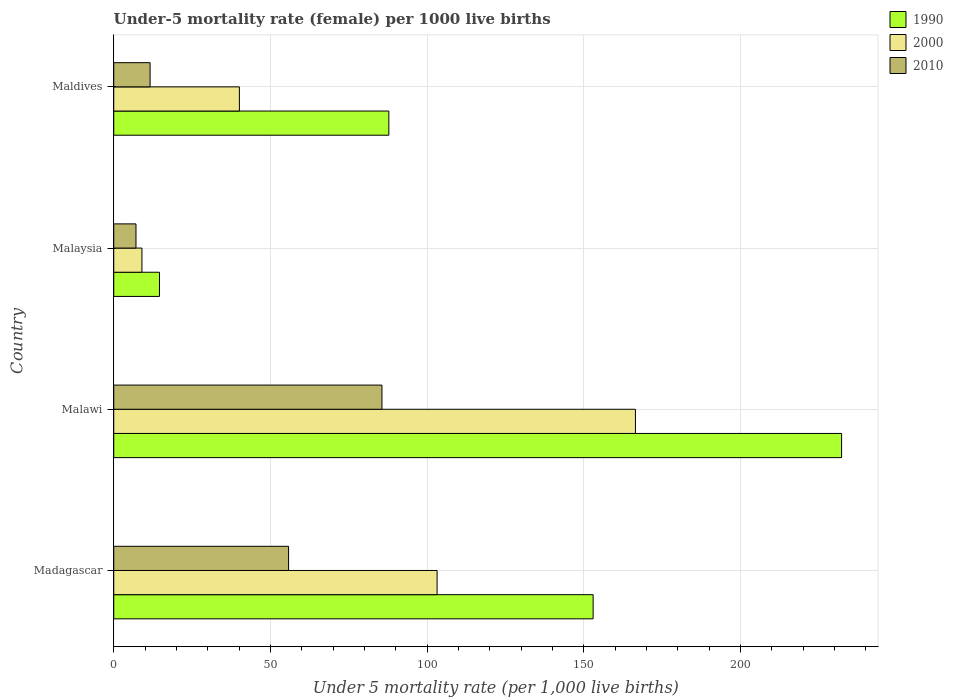What is the label of the 1st group of bars from the top?
Provide a short and direct response. Maldives. What is the under-five mortality rate in 2010 in Maldives?
Your response must be concise. 11.6. Across all countries, what is the maximum under-five mortality rate in 2000?
Give a very brief answer. 166.5. In which country was the under-five mortality rate in 2000 maximum?
Ensure brevity in your answer.  Malawi. In which country was the under-five mortality rate in 2010 minimum?
Provide a short and direct response. Malaysia. What is the total under-five mortality rate in 2000 in the graph?
Offer a very short reply. 318.8. What is the difference between the under-five mortality rate in 2000 in Malawi and that in Maldives?
Give a very brief answer. 126.4. What is the difference between the under-five mortality rate in 1990 in Malaysia and the under-five mortality rate in 2000 in Maldives?
Give a very brief answer. -25.5. What is the average under-five mortality rate in 2000 per country?
Make the answer very short. 79.7. What is the difference between the under-five mortality rate in 2010 and under-five mortality rate in 2000 in Madagascar?
Keep it short and to the point. -47.4. In how many countries, is the under-five mortality rate in 2010 greater than 140 ?
Ensure brevity in your answer.  0. Is the under-five mortality rate in 2000 in Malaysia less than that in Maldives?
Make the answer very short. Yes. What is the difference between the highest and the second highest under-five mortality rate in 2010?
Your answer should be very brief. 29.8. What is the difference between the highest and the lowest under-five mortality rate in 1990?
Offer a very short reply. 217.7. In how many countries, is the under-five mortality rate in 2010 greater than the average under-five mortality rate in 2010 taken over all countries?
Make the answer very short. 2. What does the 2nd bar from the top in Malawi represents?
Offer a very short reply. 2000. Are all the bars in the graph horizontal?
Offer a terse response. Yes. Does the graph contain any zero values?
Provide a succinct answer. No. Does the graph contain grids?
Provide a succinct answer. Yes. What is the title of the graph?
Make the answer very short. Under-5 mortality rate (female) per 1000 live births. What is the label or title of the X-axis?
Keep it short and to the point. Under 5 mortality rate (per 1,0 live births). What is the label or title of the Y-axis?
Provide a succinct answer. Country. What is the Under 5 mortality rate (per 1,000 live births) in 1990 in Madagascar?
Offer a very short reply. 153. What is the Under 5 mortality rate (per 1,000 live births) in 2000 in Madagascar?
Your answer should be very brief. 103.2. What is the Under 5 mortality rate (per 1,000 live births) in 2010 in Madagascar?
Provide a succinct answer. 55.8. What is the Under 5 mortality rate (per 1,000 live births) in 1990 in Malawi?
Your response must be concise. 232.3. What is the Under 5 mortality rate (per 1,000 live births) of 2000 in Malawi?
Offer a terse response. 166.5. What is the Under 5 mortality rate (per 1,000 live births) in 2010 in Malawi?
Keep it short and to the point. 85.6. What is the Under 5 mortality rate (per 1,000 live births) in 2000 in Malaysia?
Provide a succinct answer. 9. What is the Under 5 mortality rate (per 1,000 live births) in 1990 in Maldives?
Your answer should be compact. 87.8. What is the Under 5 mortality rate (per 1,000 live births) of 2000 in Maldives?
Make the answer very short. 40.1. What is the Under 5 mortality rate (per 1,000 live births) in 2010 in Maldives?
Your response must be concise. 11.6. Across all countries, what is the maximum Under 5 mortality rate (per 1,000 live births) in 1990?
Make the answer very short. 232.3. Across all countries, what is the maximum Under 5 mortality rate (per 1,000 live births) of 2000?
Your answer should be very brief. 166.5. Across all countries, what is the maximum Under 5 mortality rate (per 1,000 live births) of 2010?
Offer a very short reply. 85.6. Across all countries, what is the minimum Under 5 mortality rate (per 1,000 live births) of 2000?
Offer a terse response. 9. Across all countries, what is the minimum Under 5 mortality rate (per 1,000 live births) of 2010?
Make the answer very short. 7.1. What is the total Under 5 mortality rate (per 1,000 live births) in 1990 in the graph?
Your answer should be compact. 487.7. What is the total Under 5 mortality rate (per 1,000 live births) of 2000 in the graph?
Your answer should be very brief. 318.8. What is the total Under 5 mortality rate (per 1,000 live births) of 2010 in the graph?
Provide a succinct answer. 160.1. What is the difference between the Under 5 mortality rate (per 1,000 live births) in 1990 in Madagascar and that in Malawi?
Give a very brief answer. -79.3. What is the difference between the Under 5 mortality rate (per 1,000 live births) of 2000 in Madagascar and that in Malawi?
Provide a succinct answer. -63.3. What is the difference between the Under 5 mortality rate (per 1,000 live births) of 2010 in Madagascar and that in Malawi?
Ensure brevity in your answer.  -29.8. What is the difference between the Under 5 mortality rate (per 1,000 live births) of 1990 in Madagascar and that in Malaysia?
Ensure brevity in your answer.  138.4. What is the difference between the Under 5 mortality rate (per 1,000 live births) of 2000 in Madagascar and that in Malaysia?
Your response must be concise. 94.2. What is the difference between the Under 5 mortality rate (per 1,000 live births) of 2010 in Madagascar and that in Malaysia?
Provide a short and direct response. 48.7. What is the difference between the Under 5 mortality rate (per 1,000 live births) of 1990 in Madagascar and that in Maldives?
Offer a very short reply. 65.2. What is the difference between the Under 5 mortality rate (per 1,000 live births) of 2000 in Madagascar and that in Maldives?
Your answer should be compact. 63.1. What is the difference between the Under 5 mortality rate (per 1,000 live births) of 2010 in Madagascar and that in Maldives?
Ensure brevity in your answer.  44.2. What is the difference between the Under 5 mortality rate (per 1,000 live births) of 1990 in Malawi and that in Malaysia?
Your response must be concise. 217.7. What is the difference between the Under 5 mortality rate (per 1,000 live births) of 2000 in Malawi and that in Malaysia?
Offer a terse response. 157.5. What is the difference between the Under 5 mortality rate (per 1,000 live births) of 2010 in Malawi and that in Malaysia?
Provide a short and direct response. 78.5. What is the difference between the Under 5 mortality rate (per 1,000 live births) in 1990 in Malawi and that in Maldives?
Provide a short and direct response. 144.5. What is the difference between the Under 5 mortality rate (per 1,000 live births) in 2000 in Malawi and that in Maldives?
Your answer should be compact. 126.4. What is the difference between the Under 5 mortality rate (per 1,000 live births) in 1990 in Malaysia and that in Maldives?
Your response must be concise. -73.2. What is the difference between the Under 5 mortality rate (per 1,000 live births) of 2000 in Malaysia and that in Maldives?
Ensure brevity in your answer.  -31.1. What is the difference between the Under 5 mortality rate (per 1,000 live births) in 1990 in Madagascar and the Under 5 mortality rate (per 1,000 live births) in 2010 in Malawi?
Provide a succinct answer. 67.4. What is the difference between the Under 5 mortality rate (per 1,000 live births) of 2000 in Madagascar and the Under 5 mortality rate (per 1,000 live births) of 2010 in Malawi?
Provide a succinct answer. 17.6. What is the difference between the Under 5 mortality rate (per 1,000 live births) in 1990 in Madagascar and the Under 5 mortality rate (per 1,000 live births) in 2000 in Malaysia?
Your response must be concise. 144. What is the difference between the Under 5 mortality rate (per 1,000 live births) of 1990 in Madagascar and the Under 5 mortality rate (per 1,000 live births) of 2010 in Malaysia?
Make the answer very short. 145.9. What is the difference between the Under 5 mortality rate (per 1,000 live births) of 2000 in Madagascar and the Under 5 mortality rate (per 1,000 live births) of 2010 in Malaysia?
Your response must be concise. 96.1. What is the difference between the Under 5 mortality rate (per 1,000 live births) of 1990 in Madagascar and the Under 5 mortality rate (per 1,000 live births) of 2000 in Maldives?
Provide a short and direct response. 112.9. What is the difference between the Under 5 mortality rate (per 1,000 live births) of 1990 in Madagascar and the Under 5 mortality rate (per 1,000 live births) of 2010 in Maldives?
Provide a succinct answer. 141.4. What is the difference between the Under 5 mortality rate (per 1,000 live births) of 2000 in Madagascar and the Under 5 mortality rate (per 1,000 live births) of 2010 in Maldives?
Keep it short and to the point. 91.6. What is the difference between the Under 5 mortality rate (per 1,000 live births) of 1990 in Malawi and the Under 5 mortality rate (per 1,000 live births) of 2000 in Malaysia?
Your answer should be compact. 223.3. What is the difference between the Under 5 mortality rate (per 1,000 live births) in 1990 in Malawi and the Under 5 mortality rate (per 1,000 live births) in 2010 in Malaysia?
Give a very brief answer. 225.2. What is the difference between the Under 5 mortality rate (per 1,000 live births) of 2000 in Malawi and the Under 5 mortality rate (per 1,000 live births) of 2010 in Malaysia?
Your answer should be compact. 159.4. What is the difference between the Under 5 mortality rate (per 1,000 live births) in 1990 in Malawi and the Under 5 mortality rate (per 1,000 live births) in 2000 in Maldives?
Make the answer very short. 192.2. What is the difference between the Under 5 mortality rate (per 1,000 live births) in 1990 in Malawi and the Under 5 mortality rate (per 1,000 live births) in 2010 in Maldives?
Your response must be concise. 220.7. What is the difference between the Under 5 mortality rate (per 1,000 live births) in 2000 in Malawi and the Under 5 mortality rate (per 1,000 live births) in 2010 in Maldives?
Your answer should be compact. 154.9. What is the difference between the Under 5 mortality rate (per 1,000 live births) in 1990 in Malaysia and the Under 5 mortality rate (per 1,000 live births) in 2000 in Maldives?
Ensure brevity in your answer.  -25.5. What is the difference between the Under 5 mortality rate (per 1,000 live births) in 2000 in Malaysia and the Under 5 mortality rate (per 1,000 live births) in 2010 in Maldives?
Keep it short and to the point. -2.6. What is the average Under 5 mortality rate (per 1,000 live births) of 1990 per country?
Your response must be concise. 121.92. What is the average Under 5 mortality rate (per 1,000 live births) in 2000 per country?
Provide a succinct answer. 79.7. What is the average Under 5 mortality rate (per 1,000 live births) of 2010 per country?
Provide a short and direct response. 40.02. What is the difference between the Under 5 mortality rate (per 1,000 live births) in 1990 and Under 5 mortality rate (per 1,000 live births) in 2000 in Madagascar?
Ensure brevity in your answer.  49.8. What is the difference between the Under 5 mortality rate (per 1,000 live births) in 1990 and Under 5 mortality rate (per 1,000 live births) in 2010 in Madagascar?
Make the answer very short. 97.2. What is the difference between the Under 5 mortality rate (per 1,000 live births) of 2000 and Under 5 mortality rate (per 1,000 live births) of 2010 in Madagascar?
Provide a succinct answer. 47.4. What is the difference between the Under 5 mortality rate (per 1,000 live births) of 1990 and Under 5 mortality rate (per 1,000 live births) of 2000 in Malawi?
Make the answer very short. 65.8. What is the difference between the Under 5 mortality rate (per 1,000 live births) of 1990 and Under 5 mortality rate (per 1,000 live births) of 2010 in Malawi?
Provide a succinct answer. 146.7. What is the difference between the Under 5 mortality rate (per 1,000 live births) in 2000 and Under 5 mortality rate (per 1,000 live births) in 2010 in Malawi?
Your answer should be very brief. 80.9. What is the difference between the Under 5 mortality rate (per 1,000 live births) in 1990 and Under 5 mortality rate (per 1,000 live births) in 2000 in Malaysia?
Offer a terse response. 5.6. What is the difference between the Under 5 mortality rate (per 1,000 live births) of 1990 and Under 5 mortality rate (per 1,000 live births) of 2010 in Malaysia?
Offer a very short reply. 7.5. What is the difference between the Under 5 mortality rate (per 1,000 live births) of 2000 and Under 5 mortality rate (per 1,000 live births) of 2010 in Malaysia?
Ensure brevity in your answer.  1.9. What is the difference between the Under 5 mortality rate (per 1,000 live births) in 1990 and Under 5 mortality rate (per 1,000 live births) in 2000 in Maldives?
Make the answer very short. 47.7. What is the difference between the Under 5 mortality rate (per 1,000 live births) of 1990 and Under 5 mortality rate (per 1,000 live births) of 2010 in Maldives?
Provide a succinct answer. 76.2. What is the ratio of the Under 5 mortality rate (per 1,000 live births) in 1990 in Madagascar to that in Malawi?
Keep it short and to the point. 0.66. What is the ratio of the Under 5 mortality rate (per 1,000 live births) of 2000 in Madagascar to that in Malawi?
Offer a very short reply. 0.62. What is the ratio of the Under 5 mortality rate (per 1,000 live births) of 2010 in Madagascar to that in Malawi?
Provide a short and direct response. 0.65. What is the ratio of the Under 5 mortality rate (per 1,000 live births) of 1990 in Madagascar to that in Malaysia?
Your answer should be compact. 10.48. What is the ratio of the Under 5 mortality rate (per 1,000 live births) of 2000 in Madagascar to that in Malaysia?
Offer a very short reply. 11.47. What is the ratio of the Under 5 mortality rate (per 1,000 live births) of 2010 in Madagascar to that in Malaysia?
Keep it short and to the point. 7.86. What is the ratio of the Under 5 mortality rate (per 1,000 live births) in 1990 in Madagascar to that in Maldives?
Give a very brief answer. 1.74. What is the ratio of the Under 5 mortality rate (per 1,000 live births) in 2000 in Madagascar to that in Maldives?
Keep it short and to the point. 2.57. What is the ratio of the Under 5 mortality rate (per 1,000 live births) of 2010 in Madagascar to that in Maldives?
Provide a succinct answer. 4.81. What is the ratio of the Under 5 mortality rate (per 1,000 live births) in 1990 in Malawi to that in Malaysia?
Provide a short and direct response. 15.91. What is the ratio of the Under 5 mortality rate (per 1,000 live births) in 2000 in Malawi to that in Malaysia?
Keep it short and to the point. 18.5. What is the ratio of the Under 5 mortality rate (per 1,000 live births) of 2010 in Malawi to that in Malaysia?
Provide a succinct answer. 12.06. What is the ratio of the Under 5 mortality rate (per 1,000 live births) of 1990 in Malawi to that in Maldives?
Make the answer very short. 2.65. What is the ratio of the Under 5 mortality rate (per 1,000 live births) in 2000 in Malawi to that in Maldives?
Give a very brief answer. 4.15. What is the ratio of the Under 5 mortality rate (per 1,000 live births) in 2010 in Malawi to that in Maldives?
Offer a terse response. 7.38. What is the ratio of the Under 5 mortality rate (per 1,000 live births) of 1990 in Malaysia to that in Maldives?
Provide a succinct answer. 0.17. What is the ratio of the Under 5 mortality rate (per 1,000 live births) in 2000 in Malaysia to that in Maldives?
Offer a terse response. 0.22. What is the ratio of the Under 5 mortality rate (per 1,000 live births) of 2010 in Malaysia to that in Maldives?
Ensure brevity in your answer.  0.61. What is the difference between the highest and the second highest Under 5 mortality rate (per 1,000 live births) of 1990?
Your answer should be compact. 79.3. What is the difference between the highest and the second highest Under 5 mortality rate (per 1,000 live births) of 2000?
Your response must be concise. 63.3. What is the difference between the highest and the second highest Under 5 mortality rate (per 1,000 live births) of 2010?
Provide a short and direct response. 29.8. What is the difference between the highest and the lowest Under 5 mortality rate (per 1,000 live births) in 1990?
Provide a short and direct response. 217.7. What is the difference between the highest and the lowest Under 5 mortality rate (per 1,000 live births) of 2000?
Your answer should be compact. 157.5. What is the difference between the highest and the lowest Under 5 mortality rate (per 1,000 live births) of 2010?
Your answer should be very brief. 78.5. 